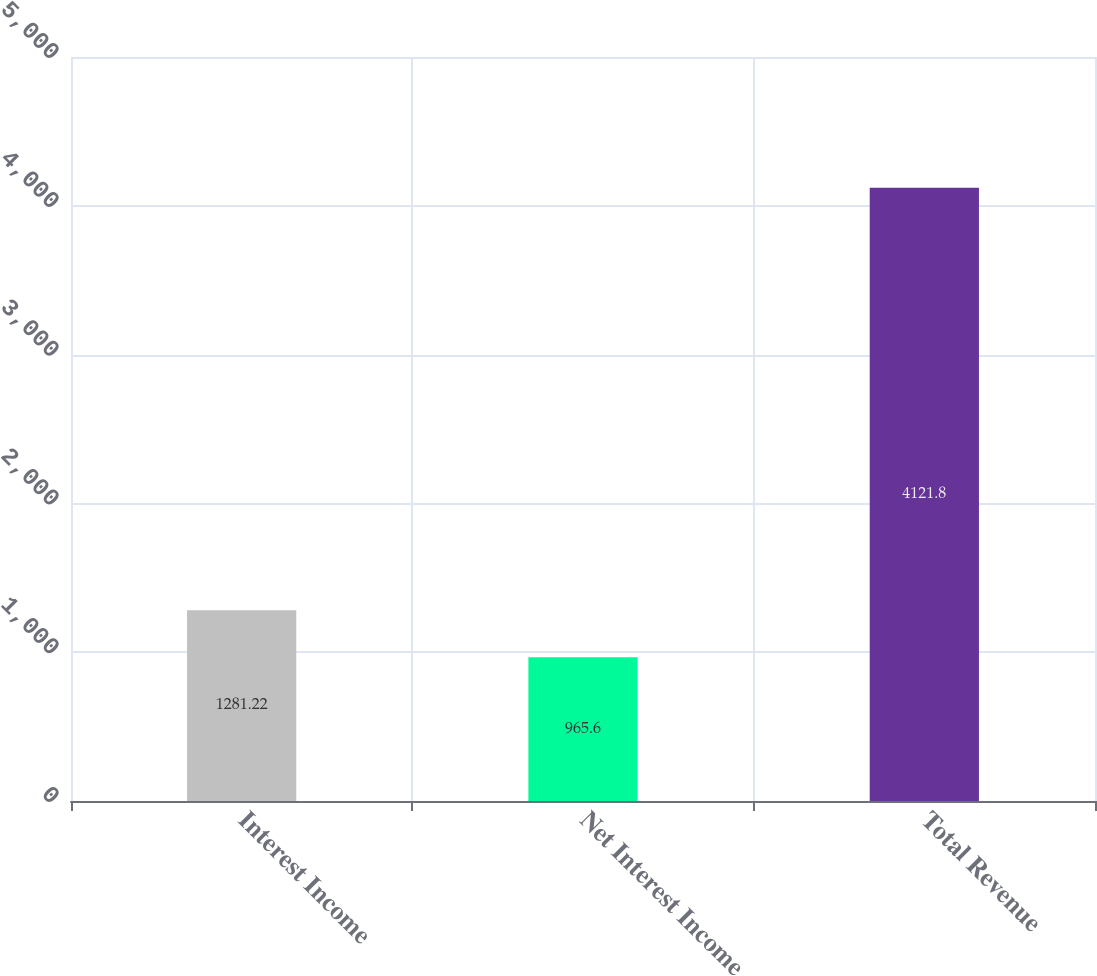<chart> <loc_0><loc_0><loc_500><loc_500><bar_chart><fcel>Interest Income<fcel>Net Interest Income<fcel>Total Revenue<nl><fcel>1281.22<fcel>965.6<fcel>4121.8<nl></chart> 